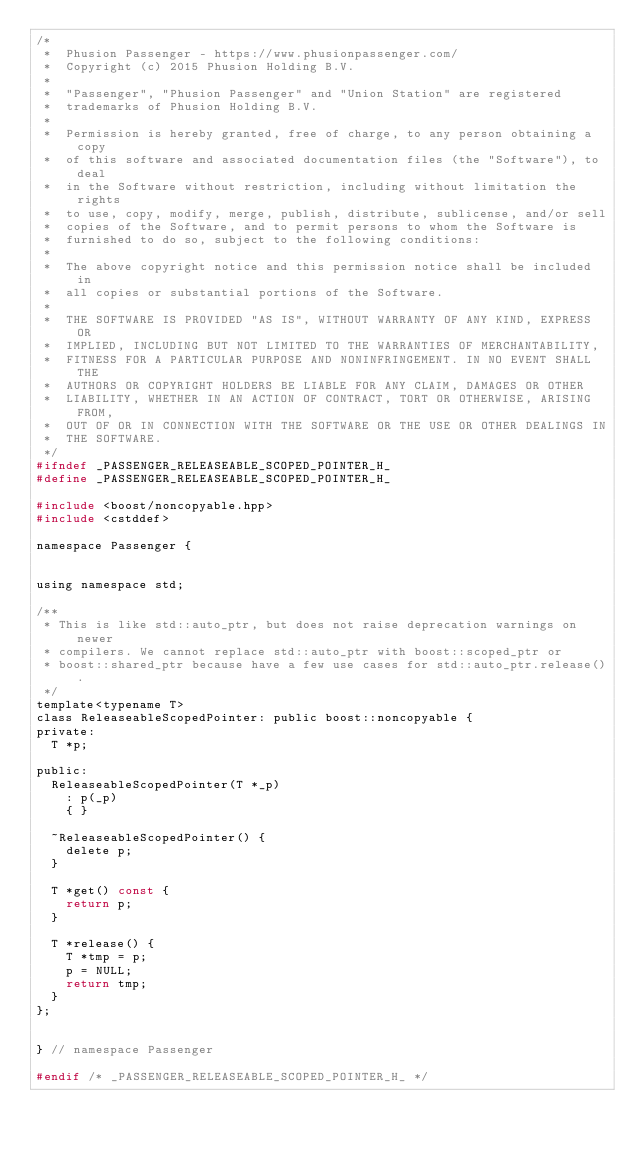<code> <loc_0><loc_0><loc_500><loc_500><_C_>/*
 *  Phusion Passenger - https://www.phusionpassenger.com/
 *  Copyright (c) 2015 Phusion Holding B.V.
 *
 *  "Passenger", "Phusion Passenger" and "Union Station" are registered
 *  trademarks of Phusion Holding B.V.
 *
 *  Permission is hereby granted, free of charge, to any person obtaining a copy
 *  of this software and associated documentation files (the "Software"), to deal
 *  in the Software without restriction, including without limitation the rights
 *  to use, copy, modify, merge, publish, distribute, sublicense, and/or sell
 *  copies of the Software, and to permit persons to whom the Software is
 *  furnished to do so, subject to the following conditions:
 *
 *  The above copyright notice and this permission notice shall be included in
 *  all copies or substantial portions of the Software.
 *
 *  THE SOFTWARE IS PROVIDED "AS IS", WITHOUT WARRANTY OF ANY KIND, EXPRESS OR
 *  IMPLIED, INCLUDING BUT NOT LIMITED TO THE WARRANTIES OF MERCHANTABILITY,
 *  FITNESS FOR A PARTICULAR PURPOSE AND NONINFRINGEMENT. IN NO EVENT SHALL THE
 *  AUTHORS OR COPYRIGHT HOLDERS BE LIABLE FOR ANY CLAIM, DAMAGES OR OTHER
 *  LIABILITY, WHETHER IN AN ACTION OF CONTRACT, TORT OR OTHERWISE, ARISING FROM,
 *  OUT OF OR IN CONNECTION WITH THE SOFTWARE OR THE USE OR OTHER DEALINGS IN
 *  THE SOFTWARE.
 */
#ifndef _PASSENGER_RELEASEABLE_SCOPED_POINTER_H_
#define _PASSENGER_RELEASEABLE_SCOPED_POINTER_H_

#include <boost/noncopyable.hpp>
#include <cstddef>

namespace Passenger {


using namespace std;

/**
 * This is like std::auto_ptr, but does not raise deprecation warnings on newer
 * compilers. We cannot replace std::auto_ptr with boost::scoped_ptr or
 * boost::shared_ptr because have a few use cases for std::auto_ptr.release().
 */
template<typename T>
class ReleaseableScopedPointer: public boost::noncopyable {
private:
	T *p;

public:
	ReleaseableScopedPointer(T *_p)
		: p(_p)
		{ }

	~ReleaseableScopedPointer() {
		delete p;
	}

	T *get() const {
		return p;
	}

	T *release() {
		T *tmp = p;
		p = NULL;
		return tmp;
	}
};


} // namespace Passenger

#endif /* _PASSENGER_RELEASEABLE_SCOPED_POINTER_H_ */
</code> 